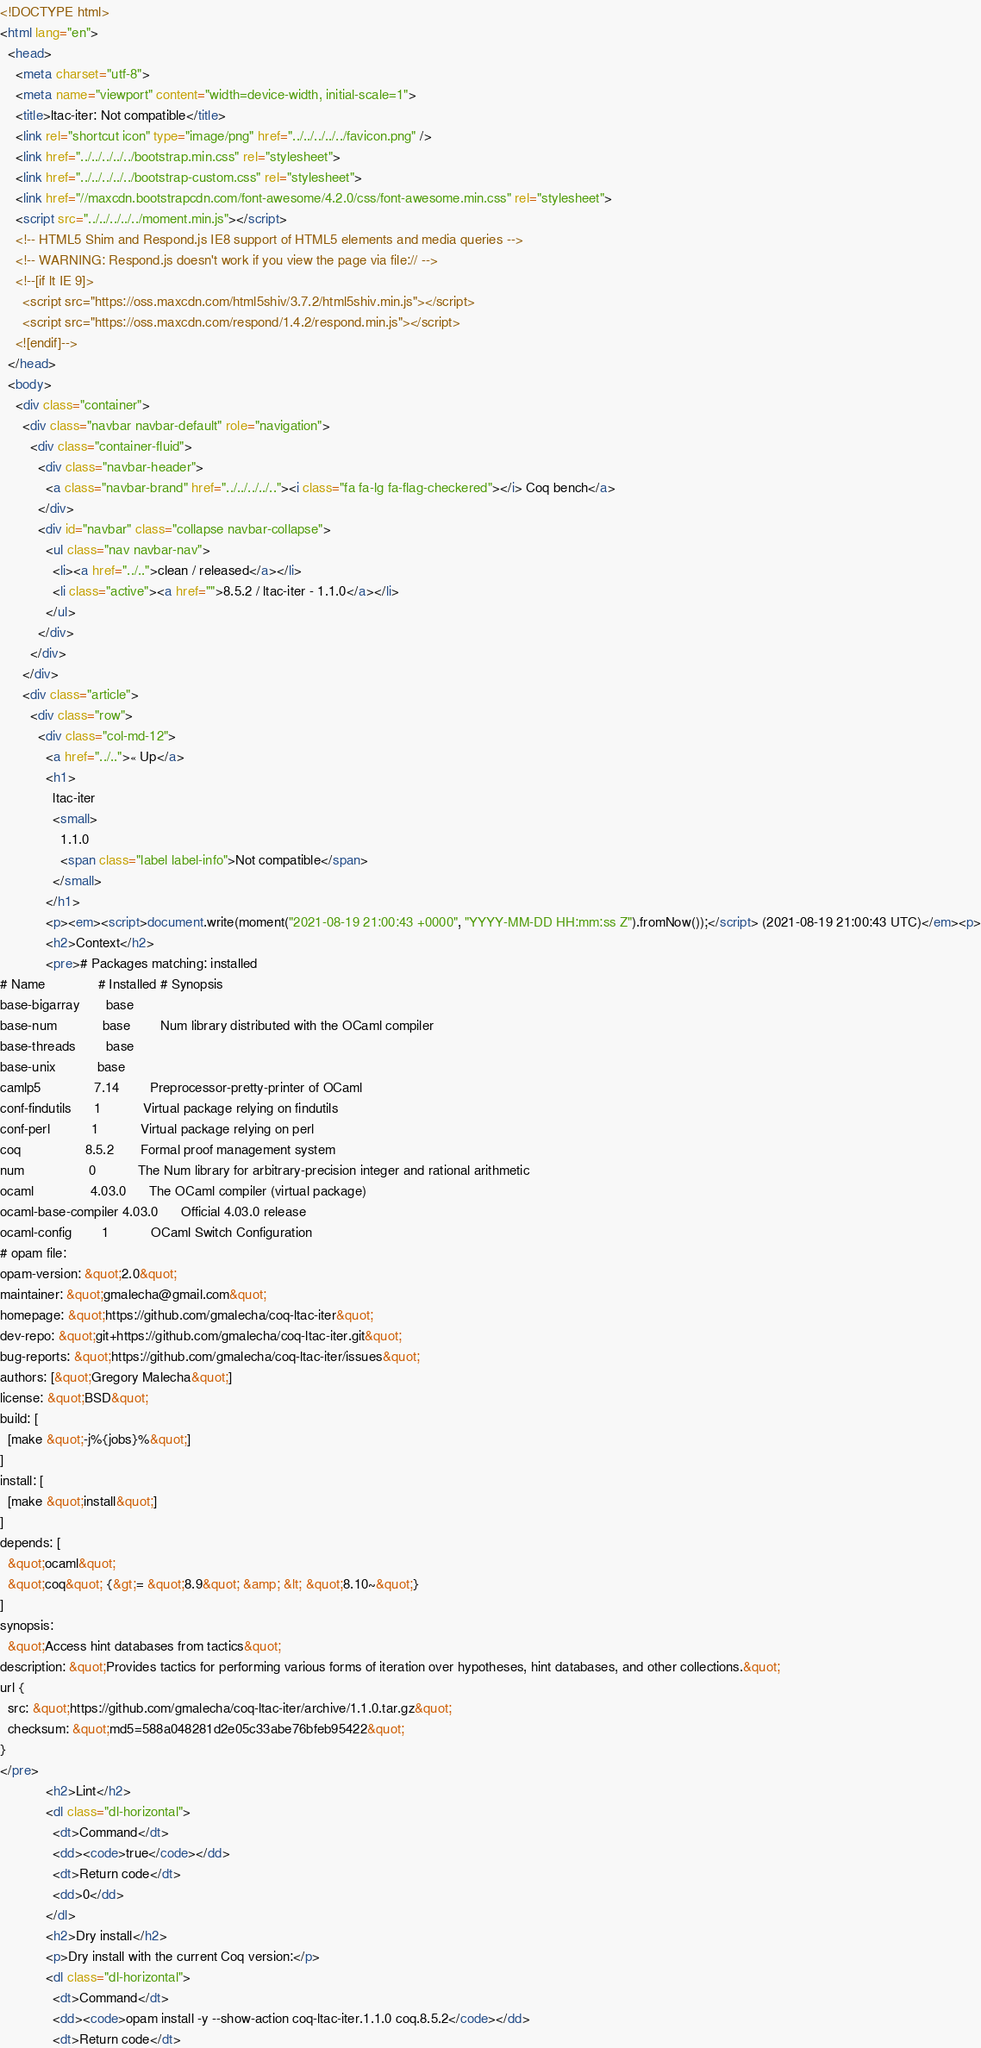<code> <loc_0><loc_0><loc_500><loc_500><_HTML_><!DOCTYPE html>
<html lang="en">
  <head>
    <meta charset="utf-8">
    <meta name="viewport" content="width=device-width, initial-scale=1">
    <title>ltac-iter: Not compatible</title>
    <link rel="shortcut icon" type="image/png" href="../../../../../favicon.png" />
    <link href="../../../../../bootstrap.min.css" rel="stylesheet">
    <link href="../../../../../bootstrap-custom.css" rel="stylesheet">
    <link href="//maxcdn.bootstrapcdn.com/font-awesome/4.2.0/css/font-awesome.min.css" rel="stylesheet">
    <script src="../../../../../moment.min.js"></script>
    <!-- HTML5 Shim and Respond.js IE8 support of HTML5 elements and media queries -->
    <!-- WARNING: Respond.js doesn't work if you view the page via file:// -->
    <!--[if lt IE 9]>
      <script src="https://oss.maxcdn.com/html5shiv/3.7.2/html5shiv.min.js"></script>
      <script src="https://oss.maxcdn.com/respond/1.4.2/respond.min.js"></script>
    <![endif]-->
  </head>
  <body>
    <div class="container">
      <div class="navbar navbar-default" role="navigation">
        <div class="container-fluid">
          <div class="navbar-header">
            <a class="navbar-brand" href="../../../../.."><i class="fa fa-lg fa-flag-checkered"></i> Coq bench</a>
          </div>
          <div id="navbar" class="collapse navbar-collapse">
            <ul class="nav navbar-nav">
              <li><a href="../..">clean / released</a></li>
              <li class="active"><a href="">8.5.2 / ltac-iter - 1.1.0</a></li>
            </ul>
          </div>
        </div>
      </div>
      <div class="article">
        <div class="row">
          <div class="col-md-12">
            <a href="../..">« Up</a>
            <h1>
              ltac-iter
              <small>
                1.1.0
                <span class="label label-info">Not compatible</span>
              </small>
            </h1>
            <p><em><script>document.write(moment("2021-08-19 21:00:43 +0000", "YYYY-MM-DD HH:mm:ss Z").fromNow());</script> (2021-08-19 21:00:43 UTC)</em><p>
            <h2>Context</h2>
            <pre># Packages matching: installed
# Name              # Installed # Synopsis
base-bigarray       base
base-num            base        Num library distributed with the OCaml compiler
base-threads        base
base-unix           base
camlp5              7.14        Preprocessor-pretty-printer of OCaml
conf-findutils      1           Virtual package relying on findutils
conf-perl           1           Virtual package relying on perl
coq                 8.5.2       Formal proof management system
num                 0           The Num library for arbitrary-precision integer and rational arithmetic
ocaml               4.03.0      The OCaml compiler (virtual package)
ocaml-base-compiler 4.03.0      Official 4.03.0 release
ocaml-config        1           OCaml Switch Configuration
# opam file:
opam-version: &quot;2.0&quot;
maintainer: &quot;gmalecha@gmail.com&quot;
homepage: &quot;https://github.com/gmalecha/coq-ltac-iter&quot;
dev-repo: &quot;git+https://github.com/gmalecha/coq-ltac-iter.git&quot;
bug-reports: &quot;https://github.com/gmalecha/coq-ltac-iter/issues&quot;
authors: [&quot;Gregory Malecha&quot;]
license: &quot;BSD&quot;
build: [
  [make &quot;-j%{jobs}%&quot;]
]
install: [
  [make &quot;install&quot;]
]
depends: [
  &quot;ocaml&quot;
  &quot;coq&quot; {&gt;= &quot;8.9&quot; &amp; &lt; &quot;8.10~&quot;}
]
synopsis:
  &quot;Access hint databases from tactics&quot;
description: &quot;Provides tactics for performing various forms of iteration over hypotheses, hint databases, and other collections.&quot;
url {
  src: &quot;https://github.com/gmalecha/coq-ltac-iter/archive/1.1.0.tar.gz&quot;
  checksum: &quot;md5=588a048281d2e05c33abe76bfeb95422&quot;
}
</pre>
            <h2>Lint</h2>
            <dl class="dl-horizontal">
              <dt>Command</dt>
              <dd><code>true</code></dd>
              <dt>Return code</dt>
              <dd>0</dd>
            </dl>
            <h2>Dry install</h2>
            <p>Dry install with the current Coq version:</p>
            <dl class="dl-horizontal">
              <dt>Command</dt>
              <dd><code>opam install -y --show-action coq-ltac-iter.1.1.0 coq.8.5.2</code></dd>
              <dt>Return code</dt></code> 